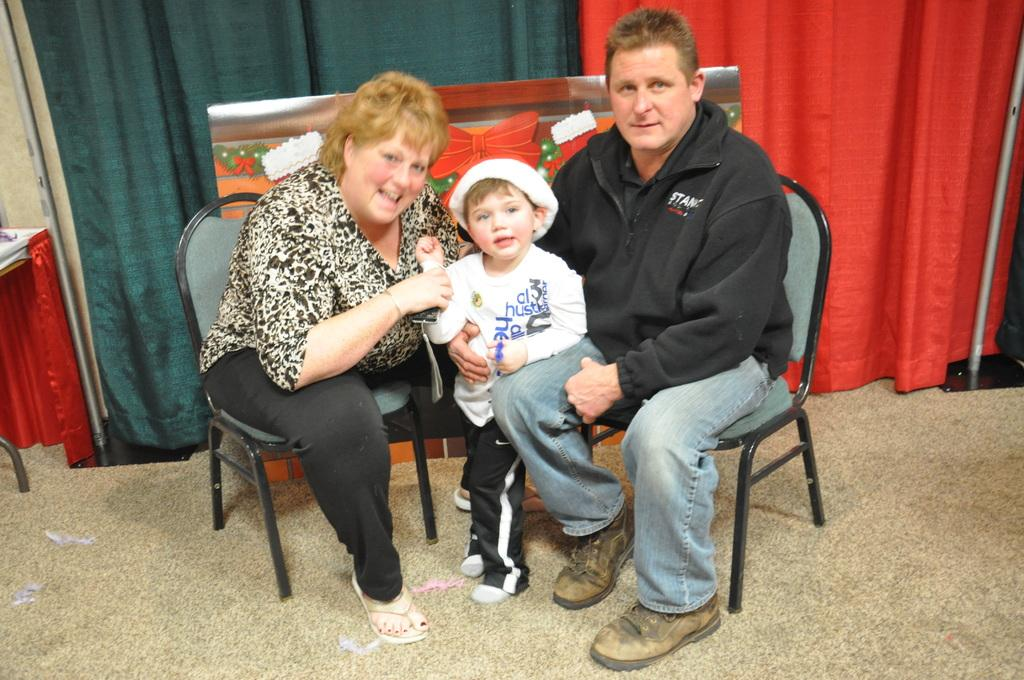How many people are in the image? There are three people in the image. What are the positions of the people in the image? Two people are seated on chairs, and one boy is standing between the seated people. What can be seen in the background of the image? There are metal rods and curtains in the background of the image. What type of grass is growing on the committee's table in the image? There is no committee or grass present in the image. 